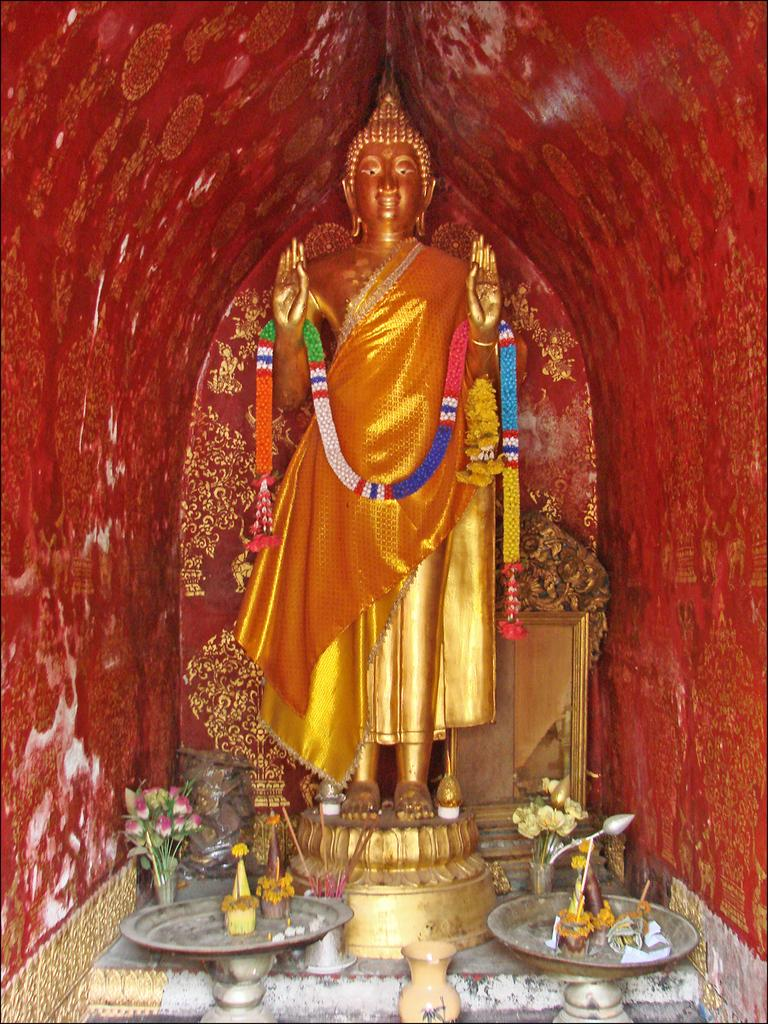What is the main subject in the center of the image? There is a statue in the center of the image. What decorative items can be seen in the image? There are garlands and flowers in the image. What objects are used for holding or containing something? There are vessels in the image. What reflective surface is present in the image? There is a mirror in the image. What can be seen on the wall in the background? There is some art on the wall. How many women are playing the guitar in the image? There are no women or guitars present in the image. What is the source of shame in the image? There is no shame or any indication of shame in the image. 